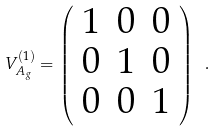<formula> <loc_0><loc_0><loc_500><loc_500>V _ { A _ { g } } ^ { ( 1 ) } = \left ( \begin{array} { c c c } 1 & 0 & 0 \\ 0 & 1 & 0 \\ 0 & 0 & 1 \\ \end{array} \right ) \ .</formula> 